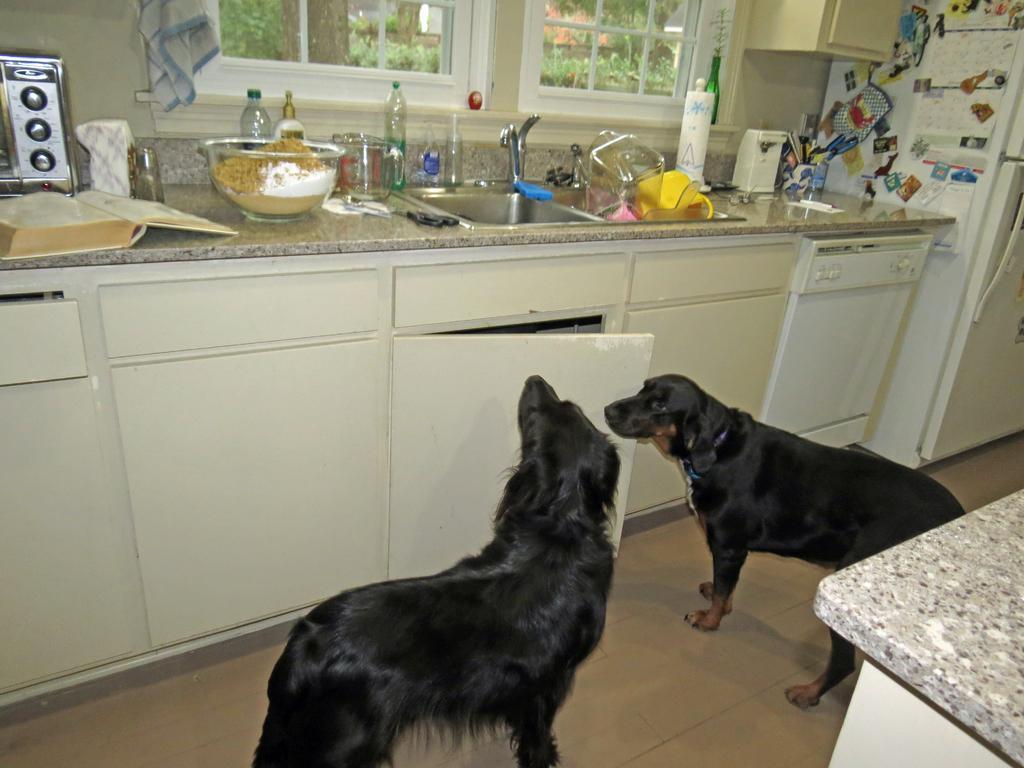Could you give a brief overview of what you see in this image? In the image there are two black dogs standing on the floor in front of kitchen floor with sink,utensils,oven and bottles on it, in front of the window. 